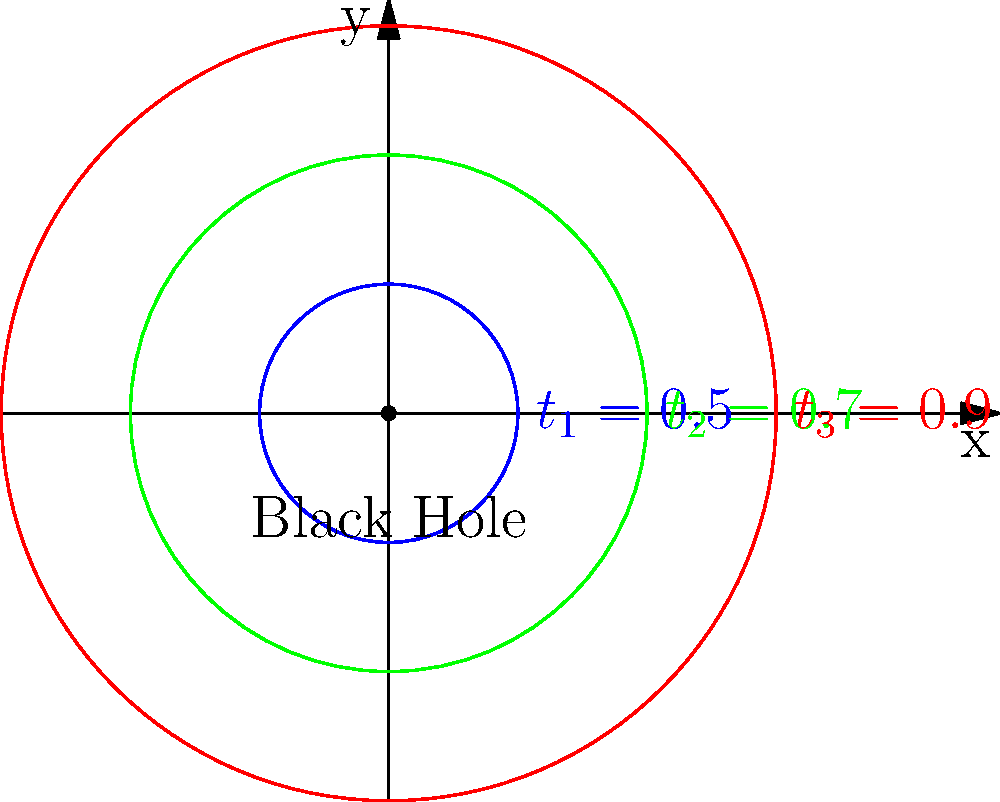Given the time dilation factors $t_1 = 0.5$, $t_2 = 0.7$, and $t_3 = 0.9$ for three different circular orbits around a black hole, as shown in the diagram, calculate the ratio of proper time experienced by an observer in the outermost orbit to that experienced by an observer in the innermost orbit during one complete revolution. Assume the angular velocity $\omega$ is constant for all orbits. To solve this problem, we'll follow these steps:

1) The time dilation factor $t$ is given by the equation:
   $$t = \sqrt{1 - \frac{2GM}{rc^2}}$$
   where $G$ is the gravitational constant, $M$ is the mass of the black hole, $r$ is the radius of the orbit, and $c$ is the speed of light.

2) The proper time $\tau$ experienced by an observer in orbit is related to the coordinate time $t$ by:
   $$d\tau = t \cdot dt$$

3) For one complete revolution, the coordinate time $T$ is given by:
   $$T = \frac{2\pi}{\omega}$$

4) The proper time experienced by an observer in each orbit for one revolution is:
   $$\tau_i = t_i \cdot T = t_i \cdot \frac{2\pi}{\omega}$$

5) The ratio of proper times between the outermost ($\tau_3$) and innermost ($\tau_1$) orbits is:
   $$\frac{\tau_3}{\tau_1} = \frac{t_3 \cdot \frac{2\pi}{\omega}}{t_1 \cdot \frac{2\pi}{\omega}} = \frac{t_3}{t_1}$$

6) Substituting the given values:
   $$\frac{\tau_3}{\tau_1} = \frac{0.9}{0.5} = 1.8$$

Therefore, an observer in the outermost orbit experiences 1.8 times more proper time than an observer in the innermost orbit during one complete revolution.
Answer: 1.8 